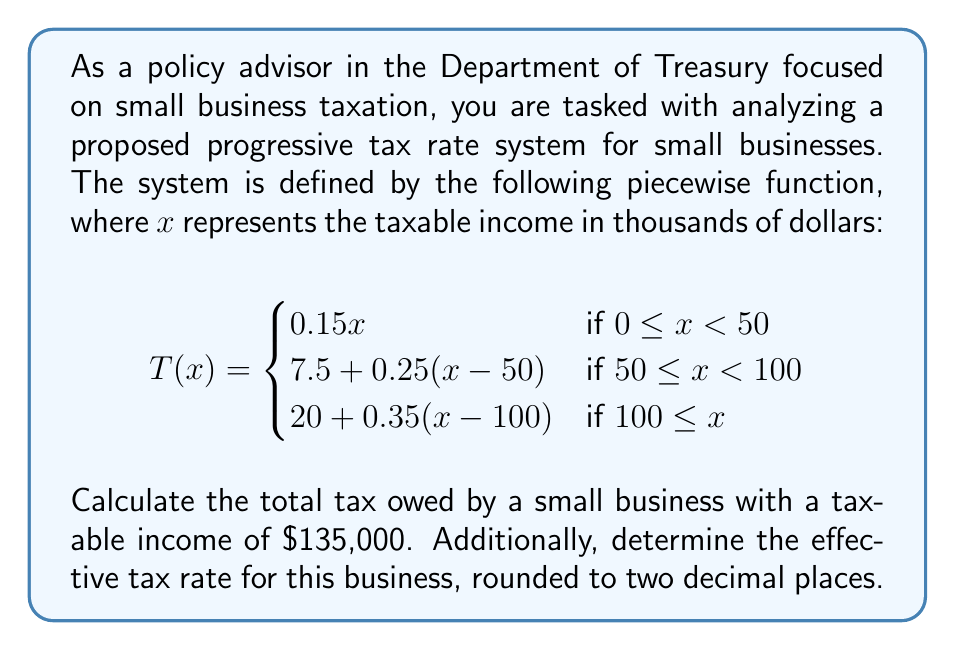Could you help me with this problem? To solve this problem, we'll follow these steps:

1. Determine which piece of the function applies to the given income.
2. Calculate the tax owed using the appropriate function.
3. Calculate the effective tax rate.

Step 1: Determine the applicable function
The taxable income is $135,000, which is represented as $x = 135$ in our function (since $x$ is in thousands of dollars). This falls into the third piece of the function, as $135 \geq 100$.

Step 2: Calculate the tax owed
We'll use the function $T(x) = 20 + 0.35(x - 100)$ for $x = 135$:

$$\begin{align*}
T(135) &= 20 + 0.35(135 - 100) \\
&= 20 + 0.35(35) \\
&= 20 + 12.25 \\
&= 32.25
\end{align*}$$

The tax owed is $32,250 (remember to multiply by 1000 since $x$ was in thousands).

Step 3: Calculate the effective tax rate
The effective tax rate is the total tax paid divided by the taxable income, expressed as a percentage:

$$\begin{align*}
\text{Effective Tax Rate} &= \frac{\text{Total Tax}}{\text{Taxable Income}} \times 100\% \\
&= \frac{32,250}{135,000} \times 100\% \\
&\approx 23.89\%
\end{align*}$$
Answer: The small business owes $32,250 in taxes, and its effective tax rate is approximately 23.89%. 